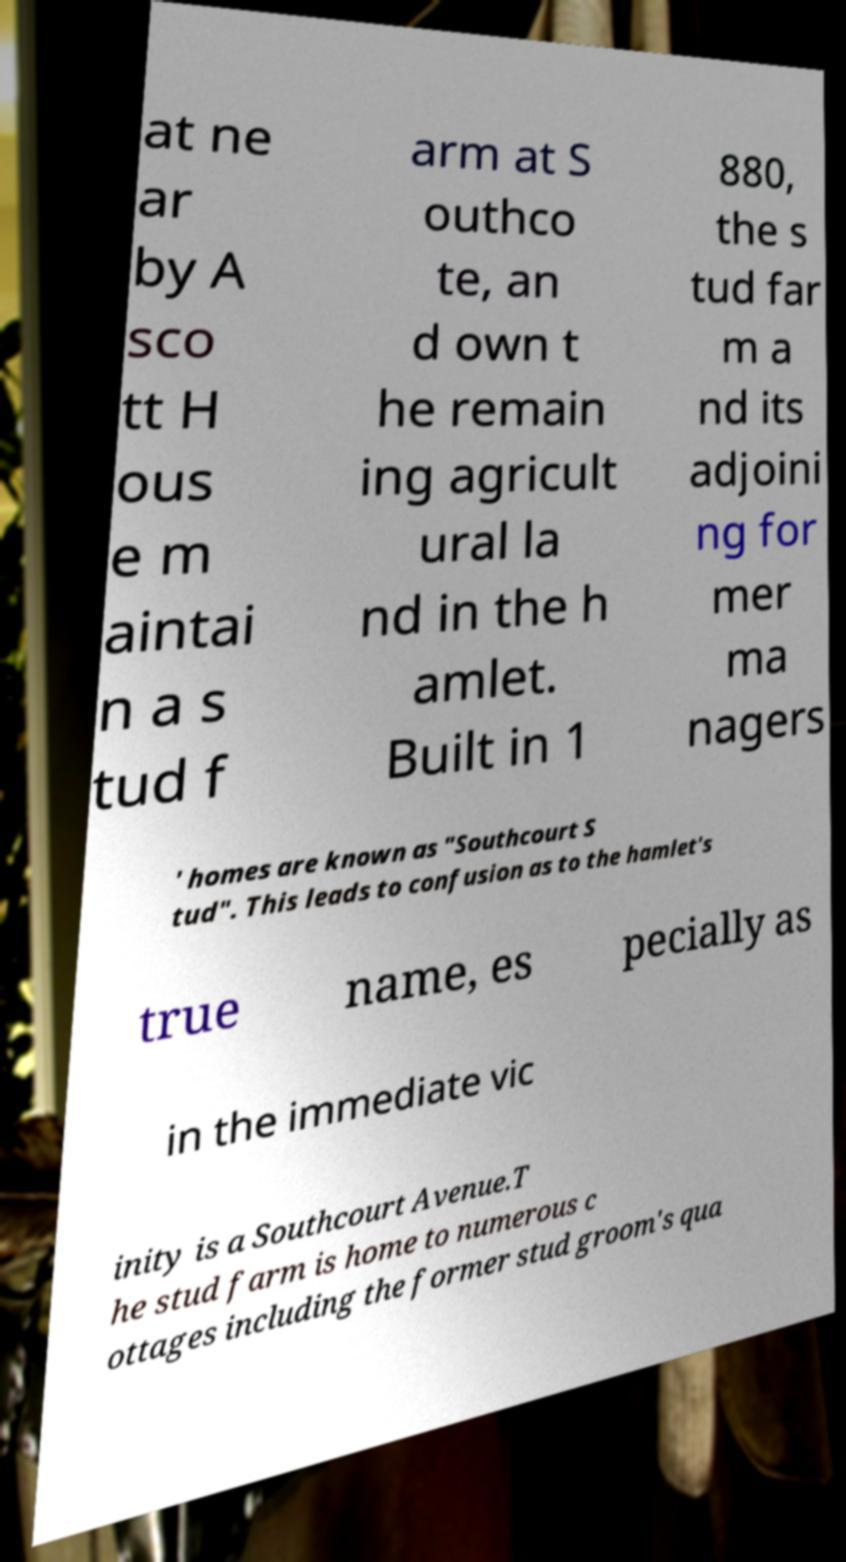Can you read and provide the text displayed in the image?This photo seems to have some interesting text. Can you extract and type it out for me? at ne ar by A sco tt H ous e m aintai n a s tud f arm at S outhco te, an d own t he remain ing agricult ural la nd in the h amlet. Built in 1 880, the s tud far m a nd its adjoini ng for mer ma nagers ' homes are known as "Southcourt S tud". This leads to confusion as to the hamlet's true name, es pecially as in the immediate vic inity is a Southcourt Avenue.T he stud farm is home to numerous c ottages including the former stud groom's qua 